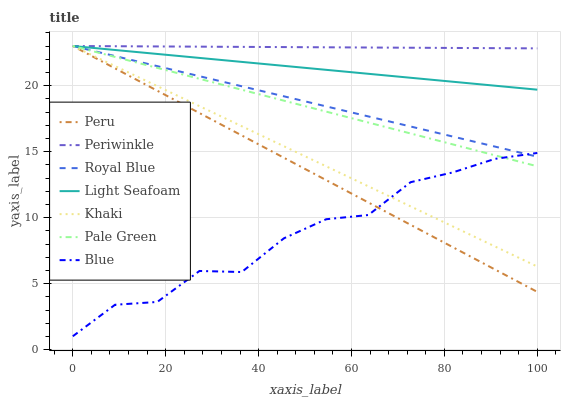Does Blue have the minimum area under the curve?
Answer yes or no. Yes. Does Periwinkle have the maximum area under the curve?
Answer yes or no. Yes. Does Khaki have the minimum area under the curve?
Answer yes or no. No. Does Khaki have the maximum area under the curve?
Answer yes or no. No. Is Periwinkle the smoothest?
Answer yes or no. Yes. Is Blue the roughest?
Answer yes or no. Yes. Is Khaki the smoothest?
Answer yes or no. No. Is Khaki the roughest?
Answer yes or no. No. Does Khaki have the lowest value?
Answer yes or no. No. Does Light Seafoam have the highest value?
Answer yes or no. Yes. Is Blue less than Light Seafoam?
Answer yes or no. Yes. Is Light Seafoam greater than Blue?
Answer yes or no. Yes. Does Blue intersect Light Seafoam?
Answer yes or no. No. 